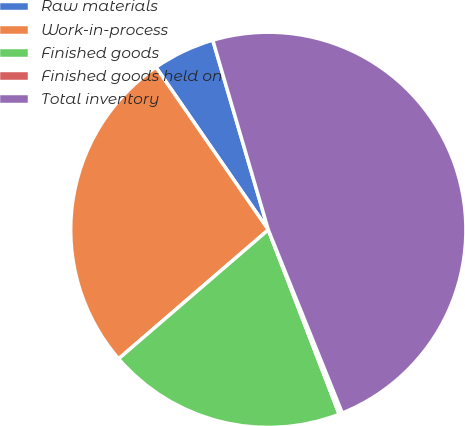Convert chart. <chart><loc_0><loc_0><loc_500><loc_500><pie_chart><fcel>Raw materials<fcel>Work-in-process<fcel>Finished goods<fcel>Finished goods held on<fcel>Total inventory<nl><fcel>5.09%<fcel>26.7%<fcel>19.52%<fcel>0.27%<fcel>48.43%<nl></chart> 